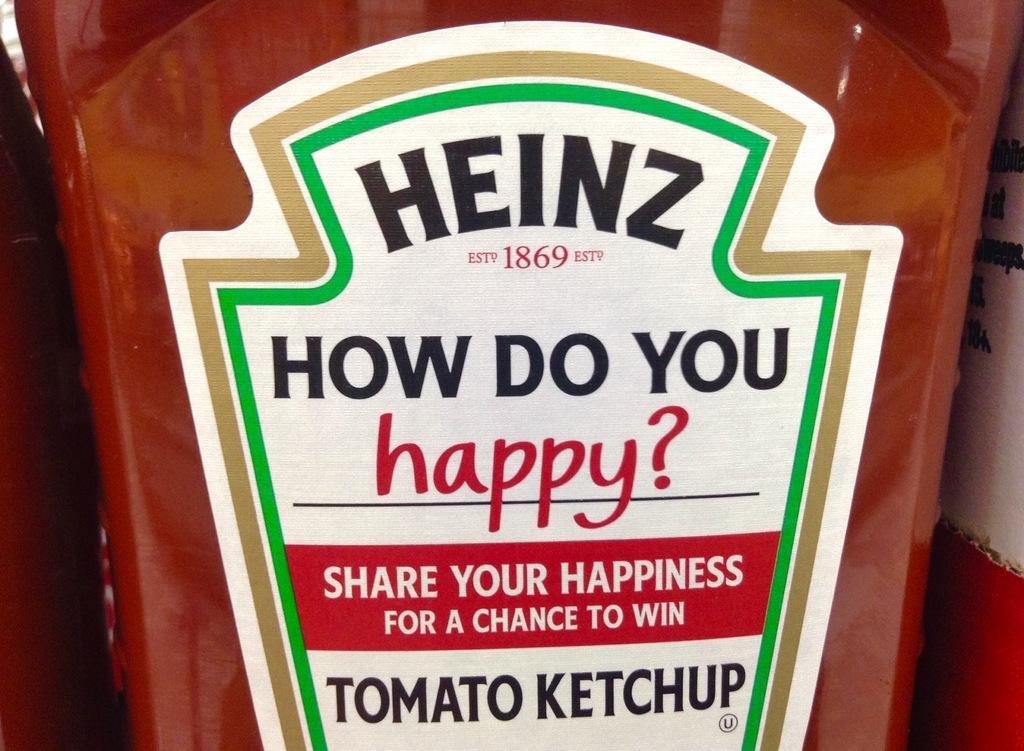Could you give a brief overview of what you see in this image? This is a tomato ketch up bottle. There is a sticker on the tomato ketch up bottle. It is written how do you happy. 